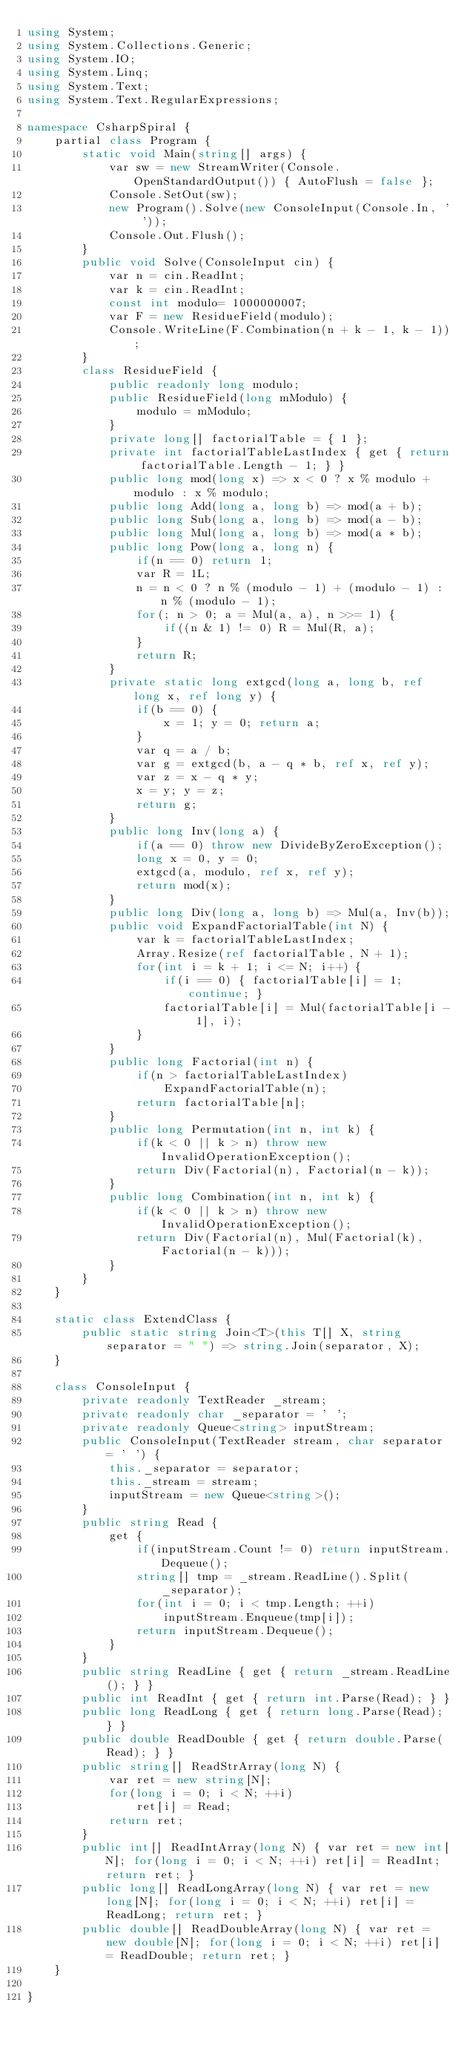<code> <loc_0><loc_0><loc_500><loc_500><_C#_>using System;
using System.Collections.Generic;
using System.IO;
using System.Linq;
using System.Text;
using System.Text.RegularExpressions;

namespace CsharpSpiral {
    partial class Program {
        static void Main(string[] args) {
            var sw = new StreamWriter(Console.OpenStandardOutput()) { AutoFlush = false };
            Console.SetOut(sw);
            new Program().Solve(new ConsoleInput(Console.In, ' '));
            Console.Out.Flush();
        }
        public void Solve(ConsoleInput cin) {
            var n = cin.ReadInt;
            var k = cin.ReadInt;
            const int modulo= 1000000007;
            var F = new ResidueField(modulo);
            Console.WriteLine(F.Combination(n + k - 1, k - 1));
        }
        class ResidueField {
            public readonly long modulo;
            public ResidueField(long mModulo) {
                modulo = mModulo;
            }
            private long[] factorialTable = { 1 };
            private int factorialTableLastIndex { get { return factorialTable.Length - 1; } }
            public long mod(long x) => x < 0 ? x % modulo + modulo : x % modulo;
            public long Add(long a, long b) => mod(a + b);
            public long Sub(long a, long b) => mod(a - b);
            public long Mul(long a, long b) => mod(a * b);
            public long Pow(long a, long n) {
                if(n == 0) return 1;
                var R = 1L;
                n = n < 0 ? n % (modulo - 1) + (modulo - 1) : n % (modulo - 1);
                for(; n > 0; a = Mul(a, a), n >>= 1) {
                    if((n & 1) != 0) R = Mul(R, a);
                }
                return R;
            }
            private static long extgcd(long a, long b, ref long x, ref long y) {
                if(b == 0) {
                    x = 1; y = 0; return a;
                }
                var q = a / b;
                var g = extgcd(b, a - q * b, ref x, ref y);
                var z = x - q * y;
                x = y; y = z;
                return g;
            }
            public long Inv(long a) {
                if(a == 0) throw new DivideByZeroException();
                long x = 0, y = 0;
                extgcd(a, modulo, ref x, ref y);
                return mod(x);
            }
            public long Div(long a, long b) => Mul(a, Inv(b));
            public void ExpandFactorialTable(int N) {
                var k = factorialTableLastIndex;
                Array.Resize(ref factorialTable, N + 1);
                for(int i = k + 1; i <= N; i++) {
                    if(i == 0) { factorialTable[i] = 1; continue; }
                    factorialTable[i] = Mul(factorialTable[i - 1], i);
                }
            }
            public long Factorial(int n) {
                if(n > factorialTableLastIndex)
                    ExpandFactorialTable(n);
                return factorialTable[n];
            }
            public long Permutation(int n, int k) {
                if(k < 0 || k > n) throw new InvalidOperationException();
                return Div(Factorial(n), Factorial(n - k));
            }
            public long Combination(int n, int k) {
                if(k < 0 || k > n) throw new InvalidOperationException();
                return Div(Factorial(n), Mul(Factorial(k), Factorial(n - k)));
            }
        }
    }

    static class ExtendClass {
        public static string Join<T>(this T[] X, string separator = " ") => string.Join(separator, X);
    }

    class ConsoleInput {
        private readonly TextReader _stream;
        private readonly char _separator = ' ';
        private readonly Queue<string> inputStream;
        public ConsoleInput(TextReader stream, char separator = ' ') {
            this._separator = separator;
            this._stream = stream;
            inputStream = new Queue<string>();
        }
        public string Read {
            get {
                if(inputStream.Count != 0) return inputStream.Dequeue();
                string[] tmp = _stream.ReadLine().Split(_separator);
                for(int i = 0; i < tmp.Length; ++i)
                    inputStream.Enqueue(tmp[i]);
                return inputStream.Dequeue();
            }
        }
        public string ReadLine { get { return _stream.ReadLine(); } }
        public int ReadInt { get { return int.Parse(Read); } }
        public long ReadLong { get { return long.Parse(Read); } }
        public double ReadDouble { get { return double.Parse(Read); } }
        public string[] ReadStrArray(long N) {
            var ret = new string[N];
            for(long i = 0; i < N; ++i)
                ret[i] = Read;
            return ret;
        }
        public int[] ReadIntArray(long N) { var ret = new int[N]; for(long i = 0; i < N; ++i) ret[i] = ReadInt; return ret; }
        public long[] ReadLongArray(long N) { var ret = new long[N]; for(long i = 0; i < N; ++i) ret[i] = ReadLong; return ret; }
        public double[] ReadDoubleArray(long N) { var ret = new double[N]; for(long i = 0; i < N; ++i) ret[i] = ReadDouble; return ret; }
    }

}

</code> 